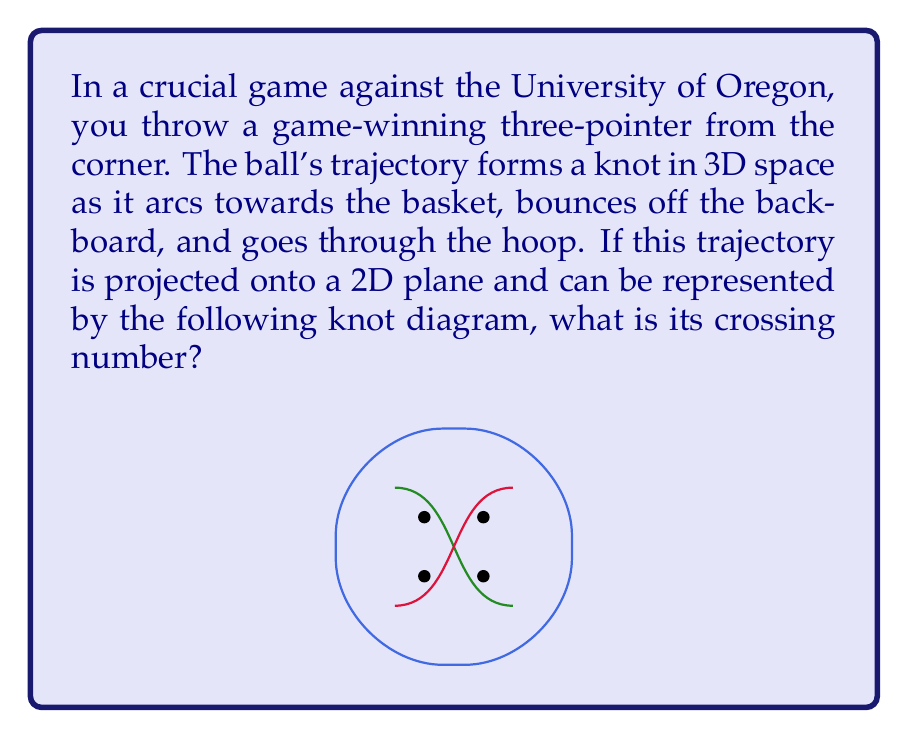Could you help me with this problem? To determine the crossing number of this knot, we need to follow these steps:

1) First, let's recall that the crossing number of a knot is the minimum number of crossings in any diagram of the knot.

2) In the given diagram, we can clearly see 4 crossing points where the knot intersects itself.

3) However, we need to verify if this is indeed the minimum number of crossings possible for this knot.

4) The knot in the diagram appears to be a figure-eight knot, which is known to have a crossing number of 4.

5) To confirm this, we can try to simplify the knot using Reidemeister moves, which are operations that can be performed on a knot diagram without changing the underlying knot:
   - Type I: Twisting or untwisting a strand
   - Type II: Moving one strand completely over another
   - Type III: Moving a strand over or under a crossing

6) After careful examination, we can see that no Reidemeister moves can reduce the number of crossings further.

7) Therefore, the crossing number of this knot is indeed 4.

This crossing number of 4 represents the complexity of your game-winning shot's trajectory, symbolizing the challenging nature of the throw that led to Oregon State's victory.
Answer: 4 